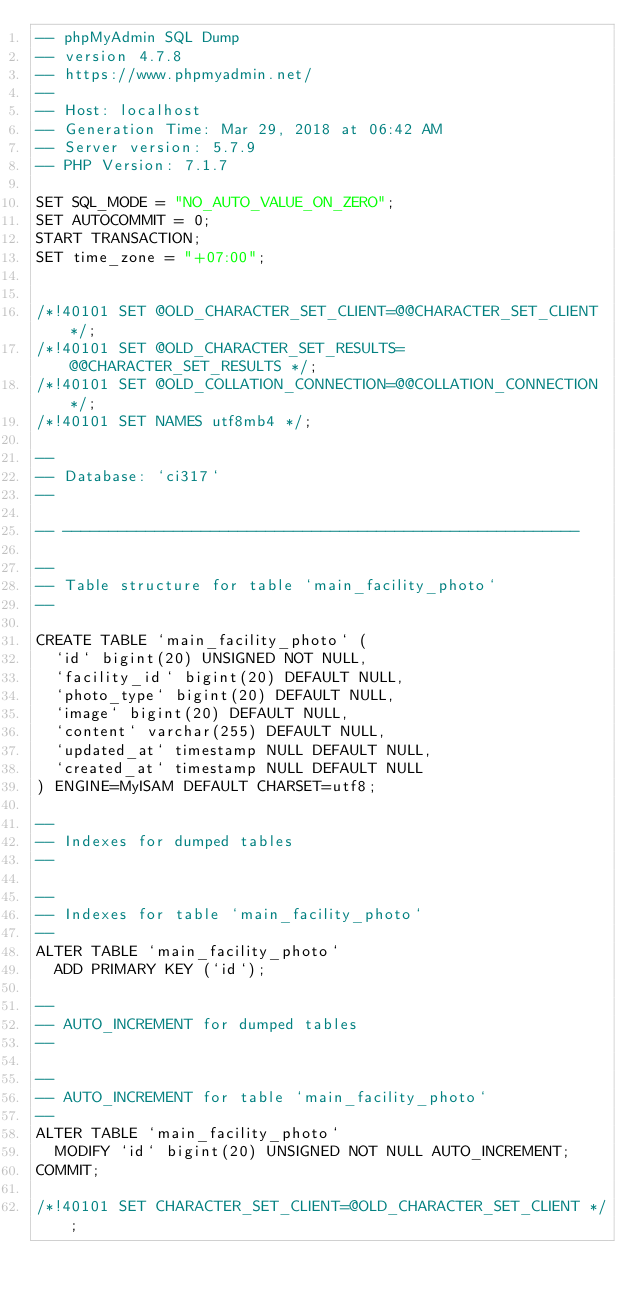<code> <loc_0><loc_0><loc_500><loc_500><_SQL_>-- phpMyAdmin SQL Dump
-- version 4.7.8
-- https://www.phpmyadmin.net/
--
-- Host: localhost
-- Generation Time: Mar 29, 2018 at 06:42 AM
-- Server version: 5.7.9
-- PHP Version: 7.1.7

SET SQL_MODE = "NO_AUTO_VALUE_ON_ZERO";
SET AUTOCOMMIT = 0;
START TRANSACTION;
SET time_zone = "+07:00";


/*!40101 SET @OLD_CHARACTER_SET_CLIENT=@@CHARACTER_SET_CLIENT */;
/*!40101 SET @OLD_CHARACTER_SET_RESULTS=@@CHARACTER_SET_RESULTS */;
/*!40101 SET @OLD_COLLATION_CONNECTION=@@COLLATION_CONNECTION */;
/*!40101 SET NAMES utf8mb4 */;

--
-- Database: `ci317`
--

-- --------------------------------------------------------

--
-- Table structure for table `main_facility_photo`
--

CREATE TABLE `main_facility_photo` (
  `id` bigint(20) UNSIGNED NOT NULL,
  `facility_id` bigint(20) DEFAULT NULL,
  `photo_type` bigint(20) DEFAULT NULL,
  `image` bigint(20) DEFAULT NULL,
  `content` varchar(255) DEFAULT NULL,
  `updated_at` timestamp NULL DEFAULT NULL,
  `created_at` timestamp NULL DEFAULT NULL
) ENGINE=MyISAM DEFAULT CHARSET=utf8;

--
-- Indexes for dumped tables
--

--
-- Indexes for table `main_facility_photo`
--
ALTER TABLE `main_facility_photo`
  ADD PRIMARY KEY (`id`);

--
-- AUTO_INCREMENT for dumped tables
--

--
-- AUTO_INCREMENT for table `main_facility_photo`
--
ALTER TABLE `main_facility_photo`
  MODIFY `id` bigint(20) UNSIGNED NOT NULL AUTO_INCREMENT;
COMMIT;

/*!40101 SET CHARACTER_SET_CLIENT=@OLD_CHARACTER_SET_CLIENT */;</code> 